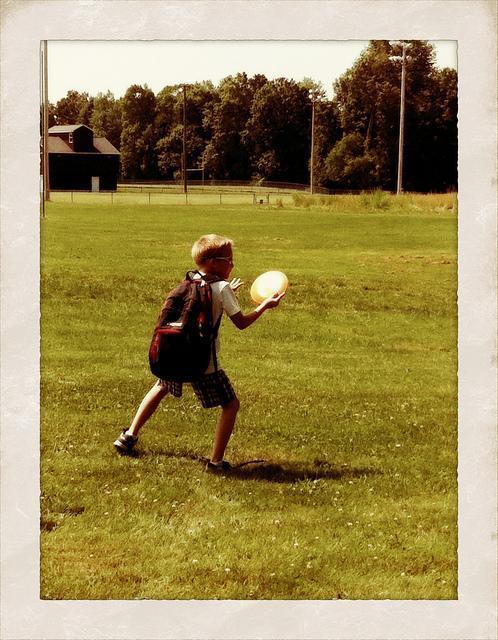How many different games are going on in the picture?
Give a very brief answer. 1. How many white computer mice are in the image?
Give a very brief answer. 0. 